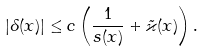<formula> <loc_0><loc_0><loc_500><loc_500>| \delta ( x ) | \leq c \left ( \frac { 1 } { s ( x ) } + \tilde { \varkappa } ( x ) \right ) .</formula> 